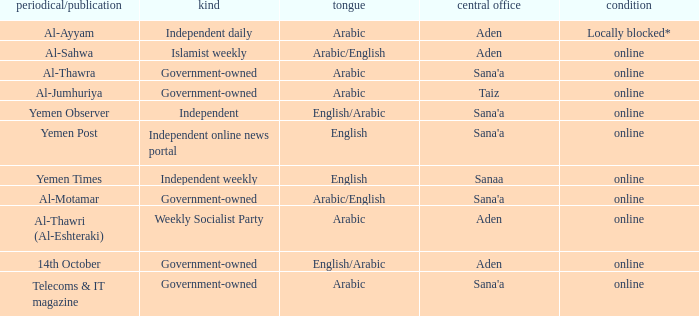What is Headquarter, when Newspaper/Magazine is Al-Ayyam? Aden. 